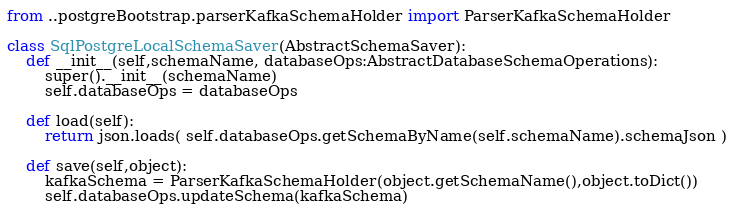Convert code to text. <code><loc_0><loc_0><loc_500><loc_500><_Python_>from ..postgreBootstrap.parserKafkaSchemaHolder import ParserKafkaSchemaHolder

class SqlPostgreLocalSchemaSaver(AbstractSchemaSaver):
    def __init__(self,schemaName, databaseOps:AbstractDatabaseSchemaOperations):
        super().__init__(schemaName)
        self.databaseOps = databaseOps

    def load(self):        
        return json.loads( self.databaseOps.getSchemaByName(self.schemaName).schemaJson )

    def save(self,object): 
        kafkaSchema = ParserKafkaSchemaHolder(object.getSchemaName(),object.toDict())
        self.databaseOps.updateSchema(kafkaSchema)
        </code> 